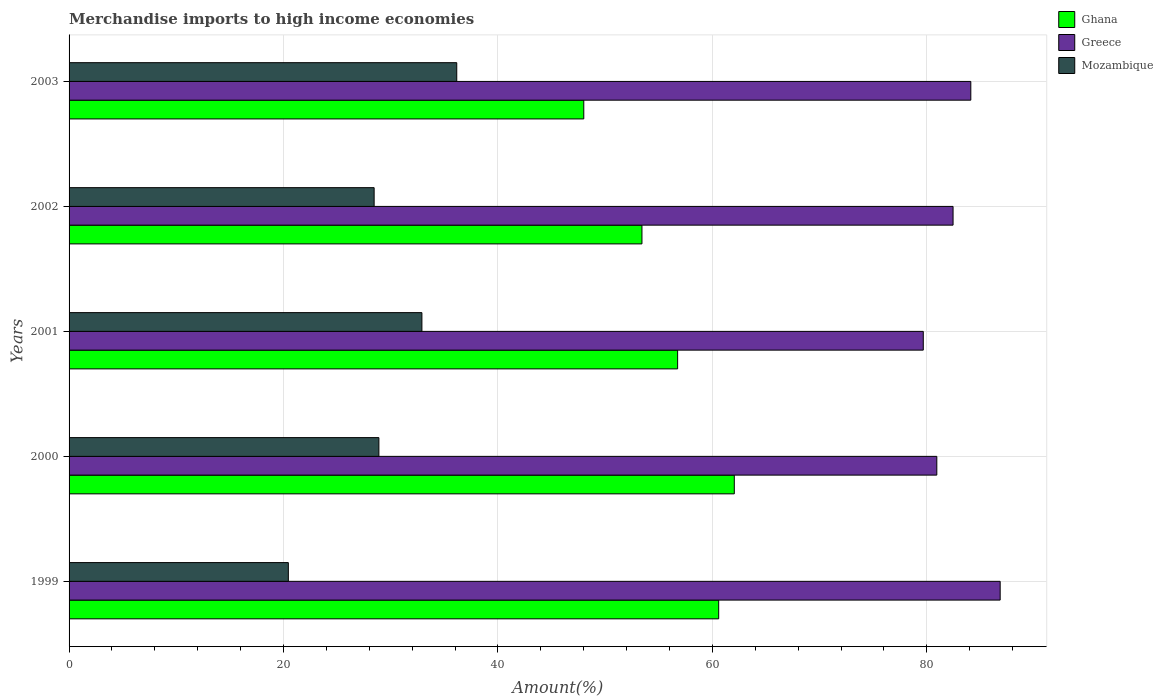How many different coloured bars are there?
Make the answer very short. 3. Are the number of bars per tick equal to the number of legend labels?
Provide a short and direct response. Yes. How many bars are there on the 3rd tick from the bottom?
Make the answer very short. 3. In how many cases, is the number of bars for a given year not equal to the number of legend labels?
Give a very brief answer. 0. What is the percentage of amount earned from merchandise imports in Ghana in 2001?
Ensure brevity in your answer.  56.76. Across all years, what is the maximum percentage of amount earned from merchandise imports in Mozambique?
Ensure brevity in your answer.  36.16. Across all years, what is the minimum percentage of amount earned from merchandise imports in Greece?
Your answer should be compact. 79.67. In which year was the percentage of amount earned from merchandise imports in Ghana maximum?
Keep it short and to the point. 2000. What is the total percentage of amount earned from merchandise imports in Greece in the graph?
Offer a terse response. 414.01. What is the difference between the percentage of amount earned from merchandise imports in Mozambique in 2001 and that in 2003?
Your answer should be compact. -3.25. What is the difference between the percentage of amount earned from merchandise imports in Greece in 2000 and the percentage of amount earned from merchandise imports in Mozambique in 1999?
Your response must be concise. 60.48. What is the average percentage of amount earned from merchandise imports in Greece per year?
Make the answer very short. 82.8. In the year 2003, what is the difference between the percentage of amount earned from merchandise imports in Mozambique and percentage of amount earned from merchandise imports in Greece?
Your response must be concise. -47.95. In how many years, is the percentage of amount earned from merchandise imports in Mozambique greater than 4 %?
Provide a short and direct response. 5. What is the ratio of the percentage of amount earned from merchandise imports in Mozambique in 2001 to that in 2003?
Offer a terse response. 0.91. What is the difference between the highest and the second highest percentage of amount earned from merchandise imports in Ghana?
Give a very brief answer. 1.46. What is the difference between the highest and the lowest percentage of amount earned from merchandise imports in Ghana?
Ensure brevity in your answer.  14.04. Is the sum of the percentage of amount earned from merchandise imports in Mozambique in 1999 and 2002 greater than the maximum percentage of amount earned from merchandise imports in Greece across all years?
Ensure brevity in your answer.  No. What does the 3rd bar from the top in 2000 represents?
Give a very brief answer. Ghana. What does the 2nd bar from the bottom in 1999 represents?
Make the answer very short. Greece. Is it the case that in every year, the sum of the percentage of amount earned from merchandise imports in Mozambique and percentage of amount earned from merchandise imports in Greece is greater than the percentage of amount earned from merchandise imports in Ghana?
Your response must be concise. Yes. How many bars are there?
Your answer should be very brief. 15. Are all the bars in the graph horizontal?
Offer a very short reply. Yes. What is the difference between two consecutive major ticks on the X-axis?
Provide a succinct answer. 20. Does the graph contain any zero values?
Keep it short and to the point. No. How many legend labels are there?
Your answer should be very brief. 3. How are the legend labels stacked?
Your answer should be very brief. Vertical. What is the title of the graph?
Offer a very short reply. Merchandise imports to high income economies. What is the label or title of the X-axis?
Offer a terse response. Amount(%). What is the Amount(%) in Ghana in 1999?
Your answer should be very brief. 60.59. What is the Amount(%) of Greece in 1999?
Your response must be concise. 86.85. What is the Amount(%) in Mozambique in 1999?
Provide a succinct answer. 20.45. What is the Amount(%) in Ghana in 2000?
Provide a short and direct response. 62.05. What is the Amount(%) of Greece in 2000?
Keep it short and to the point. 80.94. What is the Amount(%) in Mozambique in 2000?
Your answer should be very brief. 28.9. What is the Amount(%) in Ghana in 2001?
Your answer should be compact. 56.76. What is the Amount(%) in Greece in 2001?
Offer a very short reply. 79.67. What is the Amount(%) in Mozambique in 2001?
Make the answer very short. 32.91. What is the Amount(%) of Ghana in 2002?
Give a very brief answer. 53.43. What is the Amount(%) of Greece in 2002?
Offer a very short reply. 82.45. What is the Amount(%) of Mozambique in 2002?
Ensure brevity in your answer.  28.45. What is the Amount(%) in Ghana in 2003?
Keep it short and to the point. 48.01. What is the Amount(%) in Greece in 2003?
Ensure brevity in your answer.  84.11. What is the Amount(%) in Mozambique in 2003?
Your answer should be compact. 36.16. Across all years, what is the maximum Amount(%) in Ghana?
Give a very brief answer. 62.05. Across all years, what is the maximum Amount(%) in Greece?
Offer a terse response. 86.85. Across all years, what is the maximum Amount(%) in Mozambique?
Offer a terse response. 36.16. Across all years, what is the minimum Amount(%) of Ghana?
Keep it short and to the point. 48.01. Across all years, what is the minimum Amount(%) of Greece?
Offer a terse response. 79.67. Across all years, what is the minimum Amount(%) of Mozambique?
Provide a short and direct response. 20.45. What is the total Amount(%) of Ghana in the graph?
Ensure brevity in your answer.  280.84. What is the total Amount(%) of Greece in the graph?
Offer a terse response. 414.01. What is the total Amount(%) of Mozambique in the graph?
Ensure brevity in your answer.  146.87. What is the difference between the Amount(%) in Ghana in 1999 and that in 2000?
Make the answer very short. -1.46. What is the difference between the Amount(%) of Greece in 1999 and that in 2000?
Your answer should be very brief. 5.91. What is the difference between the Amount(%) of Mozambique in 1999 and that in 2000?
Ensure brevity in your answer.  -8.45. What is the difference between the Amount(%) in Ghana in 1999 and that in 2001?
Offer a very short reply. 3.83. What is the difference between the Amount(%) in Greece in 1999 and that in 2001?
Your answer should be very brief. 7.17. What is the difference between the Amount(%) in Mozambique in 1999 and that in 2001?
Your response must be concise. -12.46. What is the difference between the Amount(%) in Ghana in 1999 and that in 2002?
Provide a succinct answer. 7.16. What is the difference between the Amount(%) of Greece in 1999 and that in 2002?
Your answer should be compact. 4.39. What is the difference between the Amount(%) in Mozambique in 1999 and that in 2002?
Make the answer very short. -8. What is the difference between the Amount(%) in Ghana in 1999 and that in 2003?
Make the answer very short. 12.58. What is the difference between the Amount(%) of Greece in 1999 and that in 2003?
Your answer should be compact. 2.74. What is the difference between the Amount(%) of Mozambique in 1999 and that in 2003?
Offer a terse response. -15.71. What is the difference between the Amount(%) of Ghana in 2000 and that in 2001?
Your response must be concise. 5.29. What is the difference between the Amount(%) of Greece in 2000 and that in 2001?
Keep it short and to the point. 1.26. What is the difference between the Amount(%) in Mozambique in 2000 and that in 2001?
Keep it short and to the point. -4.01. What is the difference between the Amount(%) in Ghana in 2000 and that in 2002?
Your answer should be compact. 8.61. What is the difference between the Amount(%) in Greece in 2000 and that in 2002?
Keep it short and to the point. -1.52. What is the difference between the Amount(%) in Mozambique in 2000 and that in 2002?
Your answer should be very brief. 0.44. What is the difference between the Amount(%) in Ghana in 2000 and that in 2003?
Keep it short and to the point. 14.04. What is the difference between the Amount(%) in Greece in 2000 and that in 2003?
Provide a succinct answer. -3.17. What is the difference between the Amount(%) of Mozambique in 2000 and that in 2003?
Ensure brevity in your answer.  -7.26. What is the difference between the Amount(%) of Ghana in 2001 and that in 2002?
Make the answer very short. 3.33. What is the difference between the Amount(%) in Greece in 2001 and that in 2002?
Provide a succinct answer. -2.78. What is the difference between the Amount(%) of Mozambique in 2001 and that in 2002?
Keep it short and to the point. 4.46. What is the difference between the Amount(%) of Ghana in 2001 and that in 2003?
Offer a terse response. 8.75. What is the difference between the Amount(%) of Greece in 2001 and that in 2003?
Offer a terse response. -4.43. What is the difference between the Amount(%) of Mozambique in 2001 and that in 2003?
Offer a very short reply. -3.25. What is the difference between the Amount(%) of Ghana in 2002 and that in 2003?
Give a very brief answer. 5.43. What is the difference between the Amount(%) of Greece in 2002 and that in 2003?
Offer a very short reply. -1.65. What is the difference between the Amount(%) in Mozambique in 2002 and that in 2003?
Give a very brief answer. -7.7. What is the difference between the Amount(%) in Ghana in 1999 and the Amount(%) in Greece in 2000?
Provide a short and direct response. -20.34. What is the difference between the Amount(%) in Ghana in 1999 and the Amount(%) in Mozambique in 2000?
Offer a very short reply. 31.69. What is the difference between the Amount(%) in Greece in 1999 and the Amount(%) in Mozambique in 2000?
Your response must be concise. 57.95. What is the difference between the Amount(%) in Ghana in 1999 and the Amount(%) in Greece in 2001?
Ensure brevity in your answer.  -19.08. What is the difference between the Amount(%) in Ghana in 1999 and the Amount(%) in Mozambique in 2001?
Your answer should be very brief. 27.68. What is the difference between the Amount(%) in Greece in 1999 and the Amount(%) in Mozambique in 2001?
Give a very brief answer. 53.94. What is the difference between the Amount(%) of Ghana in 1999 and the Amount(%) of Greece in 2002?
Provide a succinct answer. -21.86. What is the difference between the Amount(%) of Ghana in 1999 and the Amount(%) of Mozambique in 2002?
Ensure brevity in your answer.  32.14. What is the difference between the Amount(%) of Greece in 1999 and the Amount(%) of Mozambique in 2002?
Give a very brief answer. 58.39. What is the difference between the Amount(%) in Ghana in 1999 and the Amount(%) in Greece in 2003?
Your response must be concise. -23.52. What is the difference between the Amount(%) of Ghana in 1999 and the Amount(%) of Mozambique in 2003?
Provide a succinct answer. 24.43. What is the difference between the Amount(%) of Greece in 1999 and the Amount(%) of Mozambique in 2003?
Ensure brevity in your answer.  50.69. What is the difference between the Amount(%) in Ghana in 2000 and the Amount(%) in Greece in 2001?
Provide a short and direct response. -17.63. What is the difference between the Amount(%) in Ghana in 2000 and the Amount(%) in Mozambique in 2001?
Your response must be concise. 29.14. What is the difference between the Amount(%) of Greece in 2000 and the Amount(%) of Mozambique in 2001?
Provide a succinct answer. 48.03. What is the difference between the Amount(%) of Ghana in 2000 and the Amount(%) of Greece in 2002?
Give a very brief answer. -20.4. What is the difference between the Amount(%) of Ghana in 2000 and the Amount(%) of Mozambique in 2002?
Give a very brief answer. 33.59. What is the difference between the Amount(%) in Greece in 2000 and the Amount(%) in Mozambique in 2002?
Your answer should be very brief. 52.48. What is the difference between the Amount(%) in Ghana in 2000 and the Amount(%) in Greece in 2003?
Your answer should be very brief. -22.06. What is the difference between the Amount(%) of Ghana in 2000 and the Amount(%) of Mozambique in 2003?
Provide a short and direct response. 25.89. What is the difference between the Amount(%) in Greece in 2000 and the Amount(%) in Mozambique in 2003?
Make the answer very short. 44.78. What is the difference between the Amount(%) of Ghana in 2001 and the Amount(%) of Greece in 2002?
Offer a very short reply. -25.69. What is the difference between the Amount(%) of Ghana in 2001 and the Amount(%) of Mozambique in 2002?
Offer a terse response. 28.31. What is the difference between the Amount(%) of Greece in 2001 and the Amount(%) of Mozambique in 2002?
Offer a very short reply. 51.22. What is the difference between the Amount(%) of Ghana in 2001 and the Amount(%) of Greece in 2003?
Your response must be concise. -27.35. What is the difference between the Amount(%) in Ghana in 2001 and the Amount(%) in Mozambique in 2003?
Make the answer very short. 20.6. What is the difference between the Amount(%) in Greece in 2001 and the Amount(%) in Mozambique in 2003?
Ensure brevity in your answer.  43.51. What is the difference between the Amount(%) in Ghana in 2002 and the Amount(%) in Greece in 2003?
Make the answer very short. -30.67. What is the difference between the Amount(%) in Ghana in 2002 and the Amount(%) in Mozambique in 2003?
Ensure brevity in your answer.  17.27. What is the difference between the Amount(%) in Greece in 2002 and the Amount(%) in Mozambique in 2003?
Offer a terse response. 46.29. What is the average Amount(%) in Ghana per year?
Keep it short and to the point. 56.17. What is the average Amount(%) in Greece per year?
Offer a very short reply. 82.8. What is the average Amount(%) of Mozambique per year?
Offer a terse response. 29.37. In the year 1999, what is the difference between the Amount(%) in Ghana and Amount(%) in Greece?
Offer a terse response. -26.25. In the year 1999, what is the difference between the Amount(%) of Ghana and Amount(%) of Mozambique?
Your answer should be compact. 40.14. In the year 1999, what is the difference between the Amount(%) of Greece and Amount(%) of Mozambique?
Your response must be concise. 66.39. In the year 2000, what is the difference between the Amount(%) in Ghana and Amount(%) in Greece?
Provide a succinct answer. -18.89. In the year 2000, what is the difference between the Amount(%) in Ghana and Amount(%) in Mozambique?
Give a very brief answer. 33.15. In the year 2000, what is the difference between the Amount(%) of Greece and Amount(%) of Mozambique?
Offer a terse response. 52.04. In the year 2001, what is the difference between the Amount(%) of Ghana and Amount(%) of Greece?
Provide a succinct answer. -22.91. In the year 2001, what is the difference between the Amount(%) in Ghana and Amount(%) in Mozambique?
Your response must be concise. 23.85. In the year 2001, what is the difference between the Amount(%) in Greece and Amount(%) in Mozambique?
Ensure brevity in your answer.  46.76. In the year 2002, what is the difference between the Amount(%) in Ghana and Amount(%) in Greece?
Your answer should be compact. -29.02. In the year 2002, what is the difference between the Amount(%) of Ghana and Amount(%) of Mozambique?
Offer a very short reply. 24.98. In the year 2002, what is the difference between the Amount(%) in Greece and Amount(%) in Mozambique?
Give a very brief answer. 54. In the year 2003, what is the difference between the Amount(%) in Ghana and Amount(%) in Greece?
Provide a short and direct response. -36.1. In the year 2003, what is the difference between the Amount(%) of Ghana and Amount(%) of Mozambique?
Provide a succinct answer. 11.85. In the year 2003, what is the difference between the Amount(%) in Greece and Amount(%) in Mozambique?
Keep it short and to the point. 47.95. What is the ratio of the Amount(%) of Ghana in 1999 to that in 2000?
Provide a short and direct response. 0.98. What is the ratio of the Amount(%) in Greece in 1999 to that in 2000?
Ensure brevity in your answer.  1.07. What is the ratio of the Amount(%) in Mozambique in 1999 to that in 2000?
Your answer should be very brief. 0.71. What is the ratio of the Amount(%) in Ghana in 1999 to that in 2001?
Give a very brief answer. 1.07. What is the ratio of the Amount(%) of Greece in 1999 to that in 2001?
Keep it short and to the point. 1.09. What is the ratio of the Amount(%) of Mozambique in 1999 to that in 2001?
Offer a very short reply. 0.62. What is the ratio of the Amount(%) of Ghana in 1999 to that in 2002?
Provide a short and direct response. 1.13. What is the ratio of the Amount(%) in Greece in 1999 to that in 2002?
Your answer should be compact. 1.05. What is the ratio of the Amount(%) in Mozambique in 1999 to that in 2002?
Your response must be concise. 0.72. What is the ratio of the Amount(%) of Ghana in 1999 to that in 2003?
Provide a succinct answer. 1.26. What is the ratio of the Amount(%) in Greece in 1999 to that in 2003?
Make the answer very short. 1.03. What is the ratio of the Amount(%) in Mozambique in 1999 to that in 2003?
Offer a terse response. 0.57. What is the ratio of the Amount(%) in Ghana in 2000 to that in 2001?
Make the answer very short. 1.09. What is the ratio of the Amount(%) of Greece in 2000 to that in 2001?
Offer a terse response. 1.02. What is the ratio of the Amount(%) of Mozambique in 2000 to that in 2001?
Provide a succinct answer. 0.88. What is the ratio of the Amount(%) in Ghana in 2000 to that in 2002?
Offer a terse response. 1.16. What is the ratio of the Amount(%) in Greece in 2000 to that in 2002?
Provide a succinct answer. 0.98. What is the ratio of the Amount(%) of Mozambique in 2000 to that in 2002?
Provide a succinct answer. 1.02. What is the ratio of the Amount(%) of Ghana in 2000 to that in 2003?
Your answer should be compact. 1.29. What is the ratio of the Amount(%) in Greece in 2000 to that in 2003?
Your response must be concise. 0.96. What is the ratio of the Amount(%) in Mozambique in 2000 to that in 2003?
Make the answer very short. 0.8. What is the ratio of the Amount(%) of Ghana in 2001 to that in 2002?
Make the answer very short. 1.06. What is the ratio of the Amount(%) in Greece in 2001 to that in 2002?
Offer a terse response. 0.97. What is the ratio of the Amount(%) of Mozambique in 2001 to that in 2002?
Make the answer very short. 1.16. What is the ratio of the Amount(%) of Ghana in 2001 to that in 2003?
Your response must be concise. 1.18. What is the ratio of the Amount(%) in Greece in 2001 to that in 2003?
Offer a terse response. 0.95. What is the ratio of the Amount(%) in Mozambique in 2001 to that in 2003?
Provide a succinct answer. 0.91. What is the ratio of the Amount(%) of Ghana in 2002 to that in 2003?
Give a very brief answer. 1.11. What is the ratio of the Amount(%) in Greece in 2002 to that in 2003?
Your answer should be compact. 0.98. What is the ratio of the Amount(%) of Mozambique in 2002 to that in 2003?
Your response must be concise. 0.79. What is the difference between the highest and the second highest Amount(%) of Ghana?
Provide a succinct answer. 1.46. What is the difference between the highest and the second highest Amount(%) in Greece?
Offer a very short reply. 2.74. What is the difference between the highest and the second highest Amount(%) of Mozambique?
Provide a succinct answer. 3.25. What is the difference between the highest and the lowest Amount(%) of Ghana?
Keep it short and to the point. 14.04. What is the difference between the highest and the lowest Amount(%) in Greece?
Keep it short and to the point. 7.17. What is the difference between the highest and the lowest Amount(%) of Mozambique?
Give a very brief answer. 15.71. 